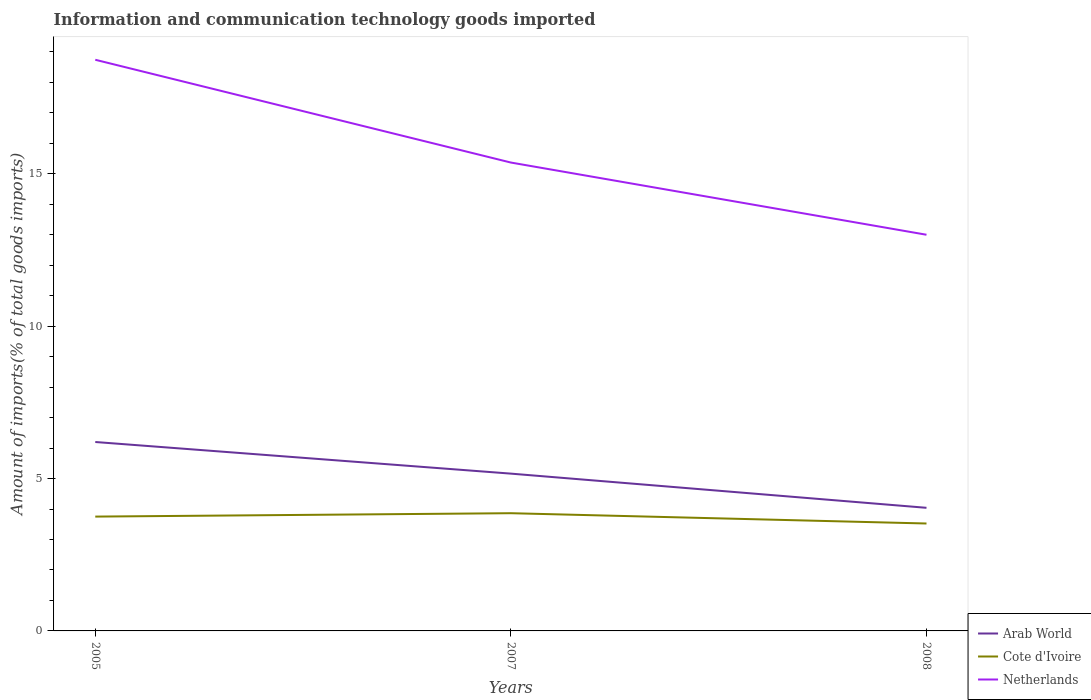How many different coloured lines are there?
Your answer should be compact. 3. Is the number of lines equal to the number of legend labels?
Give a very brief answer. Yes. Across all years, what is the maximum amount of goods imported in Arab World?
Provide a short and direct response. 4.04. In which year was the amount of goods imported in Netherlands maximum?
Ensure brevity in your answer.  2008. What is the total amount of goods imported in Netherlands in the graph?
Provide a succinct answer. 3.37. What is the difference between the highest and the second highest amount of goods imported in Cote d'Ivoire?
Keep it short and to the point. 0.34. What is the difference between the highest and the lowest amount of goods imported in Cote d'Ivoire?
Your answer should be compact. 2. How many lines are there?
Give a very brief answer. 3. What is the difference between two consecutive major ticks on the Y-axis?
Your response must be concise. 5. Are the values on the major ticks of Y-axis written in scientific E-notation?
Your response must be concise. No. How are the legend labels stacked?
Your response must be concise. Vertical. What is the title of the graph?
Provide a short and direct response. Information and communication technology goods imported. Does "Korea (Democratic)" appear as one of the legend labels in the graph?
Offer a terse response. No. What is the label or title of the X-axis?
Make the answer very short. Years. What is the label or title of the Y-axis?
Ensure brevity in your answer.  Amount of imports(% of total goods imports). What is the Amount of imports(% of total goods imports) in Arab World in 2005?
Your answer should be compact. 6.2. What is the Amount of imports(% of total goods imports) of Cote d'Ivoire in 2005?
Provide a short and direct response. 3.75. What is the Amount of imports(% of total goods imports) of Netherlands in 2005?
Your answer should be compact. 18.74. What is the Amount of imports(% of total goods imports) of Arab World in 2007?
Your answer should be very brief. 5.16. What is the Amount of imports(% of total goods imports) in Cote d'Ivoire in 2007?
Offer a very short reply. 3.86. What is the Amount of imports(% of total goods imports) of Netherlands in 2007?
Your response must be concise. 15.37. What is the Amount of imports(% of total goods imports) of Arab World in 2008?
Offer a very short reply. 4.04. What is the Amount of imports(% of total goods imports) in Cote d'Ivoire in 2008?
Your answer should be very brief. 3.53. What is the Amount of imports(% of total goods imports) in Netherlands in 2008?
Your answer should be very brief. 13. Across all years, what is the maximum Amount of imports(% of total goods imports) of Arab World?
Offer a very short reply. 6.2. Across all years, what is the maximum Amount of imports(% of total goods imports) of Cote d'Ivoire?
Provide a succinct answer. 3.86. Across all years, what is the maximum Amount of imports(% of total goods imports) of Netherlands?
Make the answer very short. 18.74. Across all years, what is the minimum Amount of imports(% of total goods imports) of Arab World?
Your answer should be very brief. 4.04. Across all years, what is the minimum Amount of imports(% of total goods imports) of Cote d'Ivoire?
Your response must be concise. 3.53. Across all years, what is the minimum Amount of imports(% of total goods imports) in Netherlands?
Your response must be concise. 13. What is the total Amount of imports(% of total goods imports) in Arab World in the graph?
Ensure brevity in your answer.  15.4. What is the total Amount of imports(% of total goods imports) in Cote d'Ivoire in the graph?
Offer a terse response. 11.14. What is the total Amount of imports(% of total goods imports) of Netherlands in the graph?
Give a very brief answer. 47.12. What is the difference between the Amount of imports(% of total goods imports) of Arab World in 2005 and that in 2007?
Offer a very short reply. 1.04. What is the difference between the Amount of imports(% of total goods imports) in Cote d'Ivoire in 2005 and that in 2007?
Offer a terse response. -0.11. What is the difference between the Amount of imports(% of total goods imports) of Netherlands in 2005 and that in 2007?
Give a very brief answer. 3.37. What is the difference between the Amount of imports(% of total goods imports) in Arab World in 2005 and that in 2008?
Keep it short and to the point. 2.16. What is the difference between the Amount of imports(% of total goods imports) of Cote d'Ivoire in 2005 and that in 2008?
Provide a succinct answer. 0.23. What is the difference between the Amount of imports(% of total goods imports) of Netherlands in 2005 and that in 2008?
Offer a very short reply. 5.74. What is the difference between the Amount of imports(% of total goods imports) of Arab World in 2007 and that in 2008?
Make the answer very short. 1.12. What is the difference between the Amount of imports(% of total goods imports) of Cote d'Ivoire in 2007 and that in 2008?
Make the answer very short. 0.34. What is the difference between the Amount of imports(% of total goods imports) in Netherlands in 2007 and that in 2008?
Ensure brevity in your answer.  2.37. What is the difference between the Amount of imports(% of total goods imports) of Arab World in 2005 and the Amount of imports(% of total goods imports) of Cote d'Ivoire in 2007?
Provide a succinct answer. 2.34. What is the difference between the Amount of imports(% of total goods imports) of Arab World in 2005 and the Amount of imports(% of total goods imports) of Netherlands in 2007?
Your response must be concise. -9.17. What is the difference between the Amount of imports(% of total goods imports) in Cote d'Ivoire in 2005 and the Amount of imports(% of total goods imports) in Netherlands in 2007?
Your answer should be very brief. -11.62. What is the difference between the Amount of imports(% of total goods imports) in Arab World in 2005 and the Amount of imports(% of total goods imports) in Cote d'Ivoire in 2008?
Ensure brevity in your answer.  2.67. What is the difference between the Amount of imports(% of total goods imports) of Arab World in 2005 and the Amount of imports(% of total goods imports) of Netherlands in 2008?
Your answer should be compact. -6.8. What is the difference between the Amount of imports(% of total goods imports) in Cote d'Ivoire in 2005 and the Amount of imports(% of total goods imports) in Netherlands in 2008?
Ensure brevity in your answer.  -9.25. What is the difference between the Amount of imports(% of total goods imports) in Arab World in 2007 and the Amount of imports(% of total goods imports) in Cote d'Ivoire in 2008?
Provide a short and direct response. 1.64. What is the difference between the Amount of imports(% of total goods imports) in Arab World in 2007 and the Amount of imports(% of total goods imports) in Netherlands in 2008?
Your answer should be very brief. -7.84. What is the difference between the Amount of imports(% of total goods imports) of Cote d'Ivoire in 2007 and the Amount of imports(% of total goods imports) of Netherlands in 2008?
Offer a terse response. -9.14. What is the average Amount of imports(% of total goods imports) in Arab World per year?
Give a very brief answer. 5.13. What is the average Amount of imports(% of total goods imports) in Cote d'Ivoire per year?
Make the answer very short. 3.71. What is the average Amount of imports(% of total goods imports) of Netherlands per year?
Your answer should be very brief. 15.71. In the year 2005, what is the difference between the Amount of imports(% of total goods imports) in Arab World and Amount of imports(% of total goods imports) in Cote d'Ivoire?
Ensure brevity in your answer.  2.45. In the year 2005, what is the difference between the Amount of imports(% of total goods imports) of Arab World and Amount of imports(% of total goods imports) of Netherlands?
Provide a succinct answer. -12.54. In the year 2005, what is the difference between the Amount of imports(% of total goods imports) of Cote d'Ivoire and Amount of imports(% of total goods imports) of Netherlands?
Your response must be concise. -14.99. In the year 2007, what is the difference between the Amount of imports(% of total goods imports) of Arab World and Amount of imports(% of total goods imports) of Cote d'Ivoire?
Give a very brief answer. 1.3. In the year 2007, what is the difference between the Amount of imports(% of total goods imports) in Arab World and Amount of imports(% of total goods imports) in Netherlands?
Your answer should be very brief. -10.21. In the year 2007, what is the difference between the Amount of imports(% of total goods imports) of Cote d'Ivoire and Amount of imports(% of total goods imports) of Netherlands?
Give a very brief answer. -11.51. In the year 2008, what is the difference between the Amount of imports(% of total goods imports) in Arab World and Amount of imports(% of total goods imports) in Cote d'Ivoire?
Offer a terse response. 0.51. In the year 2008, what is the difference between the Amount of imports(% of total goods imports) of Arab World and Amount of imports(% of total goods imports) of Netherlands?
Make the answer very short. -8.96. In the year 2008, what is the difference between the Amount of imports(% of total goods imports) in Cote d'Ivoire and Amount of imports(% of total goods imports) in Netherlands?
Give a very brief answer. -9.48. What is the ratio of the Amount of imports(% of total goods imports) in Arab World in 2005 to that in 2007?
Offer a terse response. 1.2. What is the ratio of the Amount of imports(% of total goods imports) of Cote d'Ivoire in 2005 to that in 2007?
Give a very brief answer. 0.97. What is the ratio of the Amount of imports(% of total goods imports) of Netherlands in 2005 to that in 2007?
Your response must be concise. 1.22. What is the ratio of the Amount of imports(% of total goods imports) in Arab World in 2005 to that in 2008?
Your response must be concise. 1.53. What is the ratio of the Amount of imports(% of total goods imports) in Cote d'Ivoire in 2005 to that in 2008?
Offer a very short reply. 1.06. What is the ratio of the Amount of imports(% of total goods imports) in Netherlands in 2005 to that in 2008?
Keep it short and to the point. 1.44. What is the ratio of the Amount of imports(% of total goods imports) in Arab World in 2007 to that in 2008?
Ensure brevity in your answer.  1.28. What is the ratio of the Amount of imports(% of total goods imports) in Cote d'Ivoire in 2007 to that in 2008?
Your response must be concise. 1.1. What is the ratio of the Amount of imports(% of total goods imports) in Netherlands in 2007 to that in 2008?
Your response must be concise. 1.18. What is the difference between the highest and the second highest Amount of imports(% of total goods imports) of Arab World?
Your response must be concise. 1.04. What is the difference between the highest and the second highest Amount of imports(% of total goods imports) in Cote d'Ivoire?
Ensure brevity in your answer.  0.11. What is the difference between the highest and the second highest Amount of imports(% of total goods imports) of Netherlands?
Your answer should be very brief. 3.37. What is the difference between the highest and the lowest Amount of imports(% of total goods imports) in Arab World?
Your answer should be compact. 2.16. What is the difference between the highest and the lowest Amount of imports(% of total goods imports) in Cote d'Ivoire?
Provide a short and direct response. 0.34. What is the difference between the highest and the lowest Amount of imports(% of total goods imports) of Netherlands?
Ensure brevity in your answer.  5.74. 